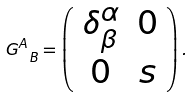<formula> <loc_0><loc_0><loc_500><loc_500>G ^ { A } _ { \ B } = \left ( \begin{array} { c c } \delta ^ { \alpha } _ { \beta } & 0 \\ 0 & s \end{array} \right ) .</formula> 